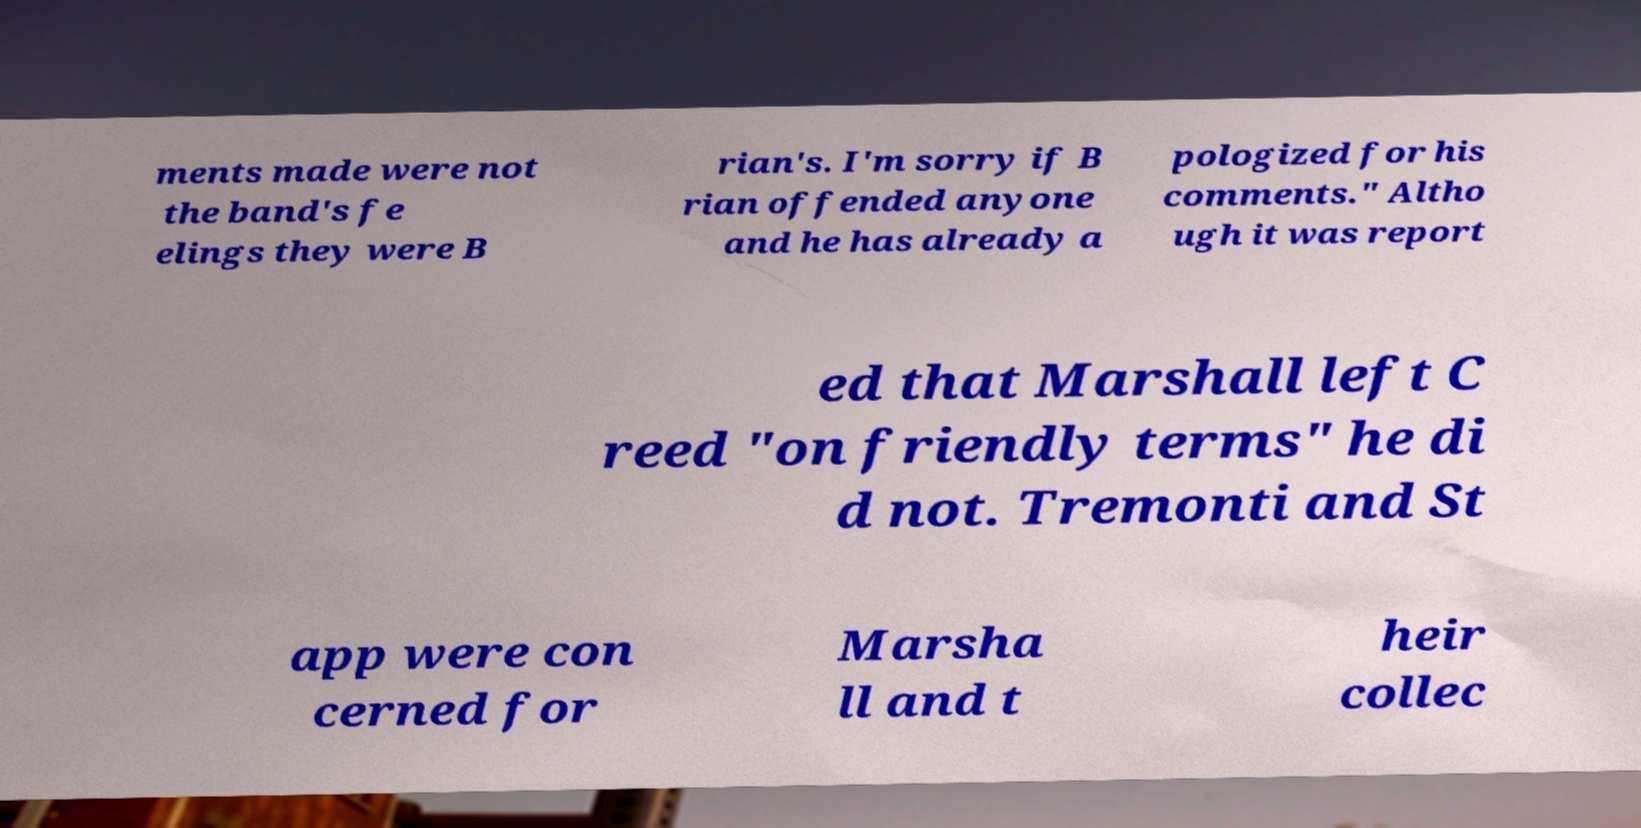Could you extract and type out the text from this image? ments made were not the band's fe elings they were B rian's. I'm sorry if B rian offended anyone and he has already a pologized for his comments." Altho ugh it was report ed that Marshall left C reed "on friendly terms" he di d not. Tremonti and St app were con cerned for Marsha ll and t heir collec 